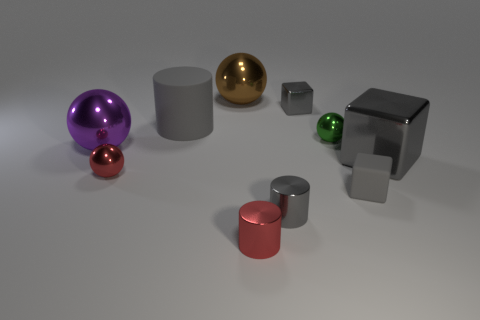Does the tiny shiny block have the same color as the big cylinder? yes 